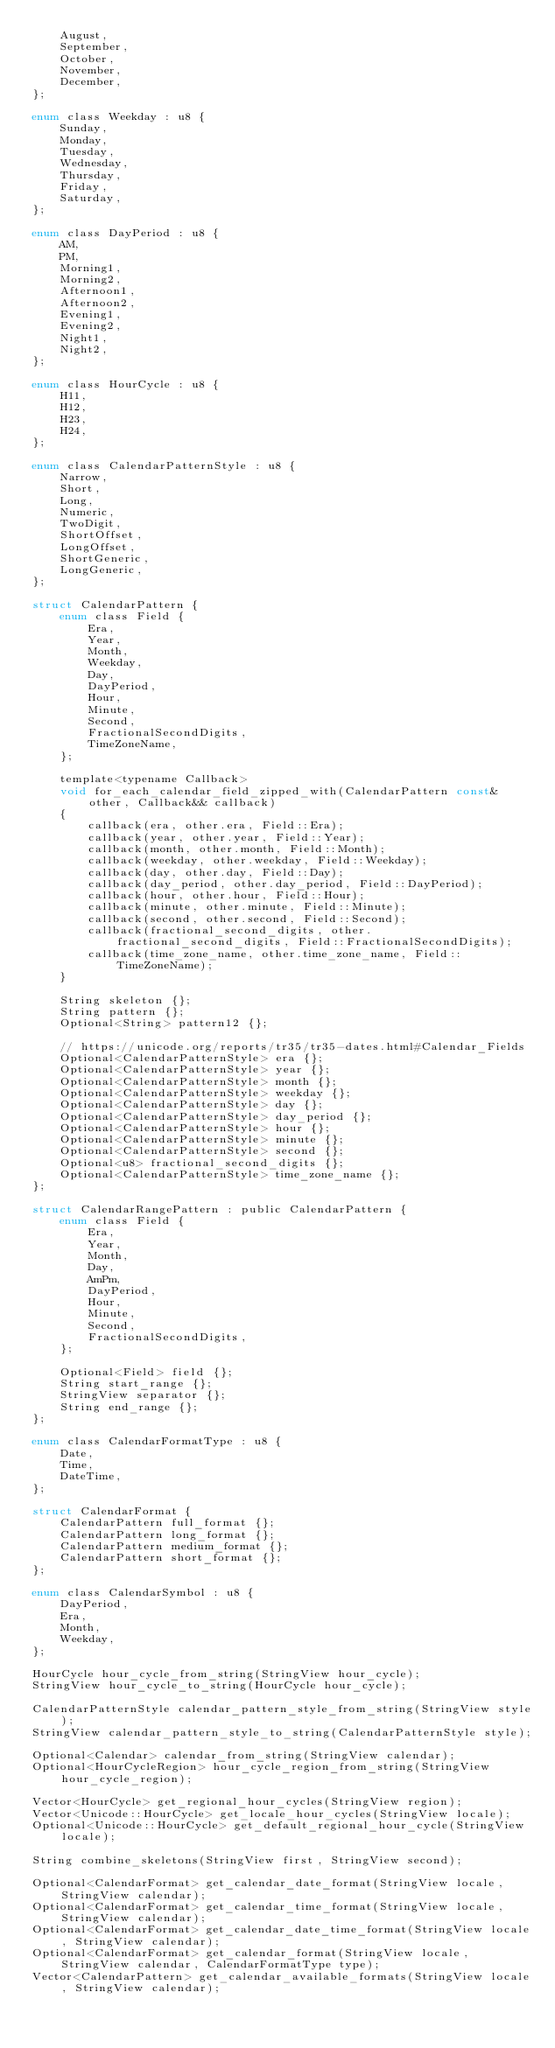Convert code to text. <code><loc_0><loc_0><loc_500><loc_500><_C_>    August,
    September,
    October,
    November,
    December,
};

enum class Weekday : u8 {
    Sunday,
    Monday,
    Tuesday,
    Wednesday,
    Thursday,
    Friday,
    Saturday,
};

enum class DayPeriod : u8 {
    AM,
    PM,
    Morning1,
    Morning2,
    Afternoon1,
    Afternoon2,
    Evening1,
    Evening2,
    Night1,
    Night2,
};

enum class HourCycle : u8 {
    H11,
    H12,
    H23,
    H24,
};

enum class CalendarPatternStyle : u8 {
    Narrow,
    Short,
    Long,
    Numeric,
    TwoDigit,
    ShortOffset,
    LongOffset,
    ShortGeneric,
    LongGeneric,
};

struct CalendarPattern {
    enum class Field {
        Era,
        Year,
        Month,
        Weekday,
        Day,
        DayPeriod,
        Hour,
        Minute,
        Second,
        FractionalSecondDigits,
        TimeZoneName,
    };

    template<typename Callback>
    void for_each_calendar_field_zipped_with(CalendarPattern const& other, Callback&& callback)
    {
        callback(era, other.era, Field::Era);
        callback(year, other.year, Field::Year);
        callback(month, other.month, Field::Month);
        callback(weekday, other.weekday, Field::Weekday);
        callback(day, other.day, Field::Day);
        callback(day_period, other.day_period, Field::DayPeriod);
        callback(hour, other.hour, Field::Hour);
        callback(minute, other.minute, Field::Minute);
        callback(second, other.second, Field::Second);
        callback(fractional_second_digits, other.fractional_second_digits, Field::FractionalSecondDigits);
        callback(time_zone_name, other.time_zone_name, Field::TimeZoneName);
    }

    String skeleton {};
    String pattern {};
    Optional<String> pattern12 {};

    // https://unicode.org/reports/tr35/tr35-dates.html#Calendar_Fields
    Optional<CalendarPatternStyle> era {};
    Optional<CalendarPatternStyle> year {};
    Optional<CalendarPatternStyle> month {};
    Optional<CalendarPatternStyle> weekday {};
    Optional<CalendarPatternStyle> day {};
    Optional<CalendarPatternStyle> day_period {};
    Optional<CalendarPatternStyle> hour {};
    Optional<CalendarPatternStyle> minute {};
    Optional<CalendarPatternStyle> second {};
    Optional<u8> fractional_second_digits {};
    Optional<CalendarPatternStyle> time_zone_name {};
};

struct CalendarRangePattern : public CalendarPattern {
    enum class Field {
        Era,
        Year,
        Month,
        Day,
        AmPm,
        DayPeriod,
        Hour,
        Minute,
        Second,
        FractionalSecondDigits,
    };

    Optional<Field> field {};
    String start_range {};
    StringView separator {};
    String end_range {};
};

enum class CalendarFormatType : u8 {
    Date,
    Time,
    DateTime,
};

struct CalendarFormat {
    CalendarPattern full_format {};
    CalendarPattern long_format {};
    CalendarPattern medium_format {};
    CalendarPattern short_format {};
};

enum class CalendarSymbol : u8 {
    DayPeriod,
    Era,
    Month,
    Weekday,
};

HourCycle hour_cycle_from_string(StringView hour_cycle);
StringView hour_cycle_to_string(HourCycle hour_cycle);

CalendarPatternStyle calendar_pattern_style_from_string(StringView style);
StringView calendar_pattern_style_to_string(CalendarPatternStyle style);

Optional<Calendar> calendar_from_string(StringView calendar);
Optional<HourCycleRegion> hour_cycle_region_from_string(StringView hour_cycle_region);

Vector<HourCycle> get_regional_hour_cycles(StringView region);
Vector<Unicode::HourCycle> get_locale_hour_cycles(StringView locale);
Optional<Unicode::HourCycle> get_default_regional_hour_cycle(StringView locale);

String combine_skeletons(StringView first, StringView second);

Optional<CalendarFormat> get_calendar_date_format(StringView locale, StringView calendar);
Optional<CalendarFormat> get_calendar_time_format(StringView locale, StringView calendar);
Optional<CalendarFormat> get_calendar_date_time_format(StringView locale, StringView calendar);
Optional<CalendarFormat> get_calendar_format(StringView locale, StringView calendar, CalendarFormatType type);
Vector<CalendarPattern> get_calendar_available_formats(StringView locale, StringView calendar);</code> 